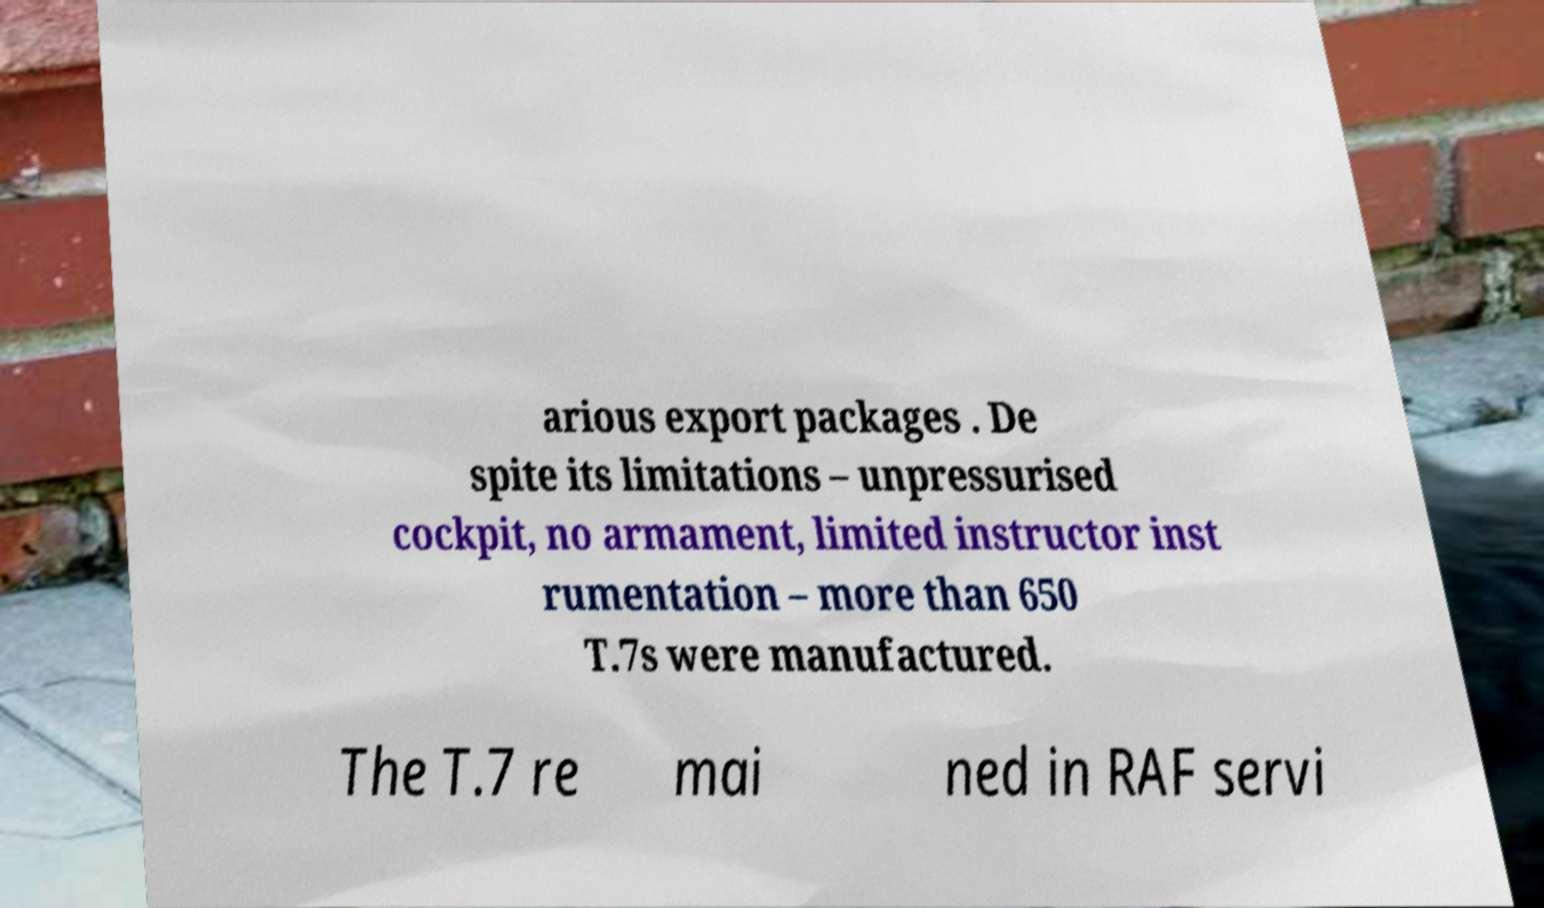What messages or text are displayed in this image? I need them in a readable, typed format. arious export packages . De spite its limitations – unpressurised cockpit, no armament, limited instructor inst rumentation – more than 650 T.7s were manufactured. The T.7 re mai ned in RAF servi 